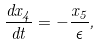<formula> <loc_0><loc_0><loc_500><loc_500>\frac { d x _ { 4 } } { d t } = - \frac { x _ { 5 } } { \epsilon } ,</formula> 